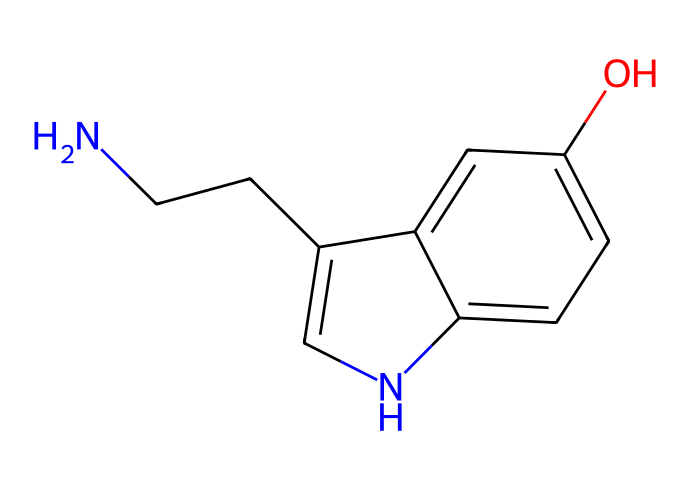What is the molecular formula of the chemical represented by this SMILES? By analyzing the SMILES notation, we can identify the types and numbers of atoms present in the molecule. The notation indicates the presence of nitrogen (N), carbon (C), and oxygen (O) atoms. Counting these gives a total of 11 carbon atoms, 14 hydrogen atoms, 1 nitrogen atom, and 1 oxygen atom. Therefore, the molecular formula is C11H14N2O.
Answer: C11H14N2O How many aromatic rings are present in this structure? Examining the chemical structure from the SMILES reveals that there are two distinct aromatic rings present, which can be identified by the alternating double bonds and conjugated system. This confirms that the structure includes two connected aromatic systems.
Answer: 2 What functional group is present in the chemical? The structure has a hydroxyl group (–OH) as indicated by the presence of an oxygen atom bonded to a hydrogen atom. This functional group contributes to the chemical properties of the molecule, such as solubility and reactivity.
Answer: hydroxyl group What role does the nitrogen atom play in the compound structure? In this compound, the nitrogen atom is part of an indole framework, which is crucial for its behavior as a neurotransmitter. Nitrogen's capacity to participate in hydrogen bonding can influence the molecule's interactions with biological receptors.
Answer: neurotransmitter role Is this chemical likely to be soluble in water? Based on the presence of the hydroxyl group and the nitrogen atom, which can both engage in hydrogen bonding with water molecules, it's reasonable to conclude that this compound would exhibit some degree of solubility in water.
Answer: yes How many hydrogen atoms are directly attached to the nitrogen atom in this structure? The SMILES notation shows that the nitrogen atom is attached to one carbon, which in turn connects to two hydrogen atoms. Therefore, only one hydrogen atom is directly bonded to the nitrogen.
Answer: 1 